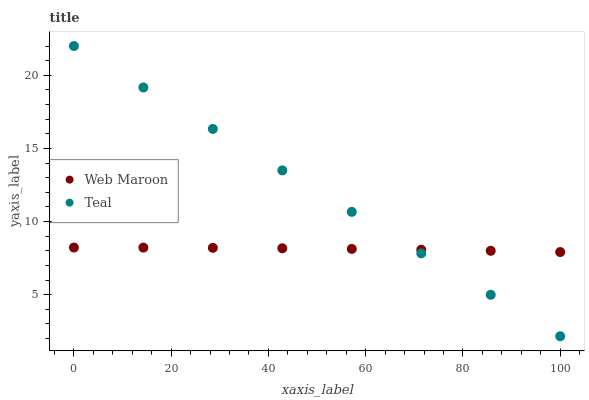Does Web Maroon have the minimum area under the curve?
Answer yes or no. Yes. Does Teal have the maximum area under the curve?
Answer yes or no. Yes. Does Teal have the minimum area under the curve?
Answer yes or no. No. Is Teal the smoothest?
Answer yes or no. Yes. Is Web Maroon the roughest?
Answer yes or no. Yes. Is Teal the roughest?
Answer yes or no. No. Does Teal have the lowest value?
Answer yes or no. Yes. Does Teal have the highest value?
Answer yes or no. Yes. Does Teal intersect Web Maroon?
Answer yes or no. Yes. Is Teal less than Web Maroon?
Answer yes or no. No. Is Teal greater than Web Maroon?
Answer yes or no. No. 